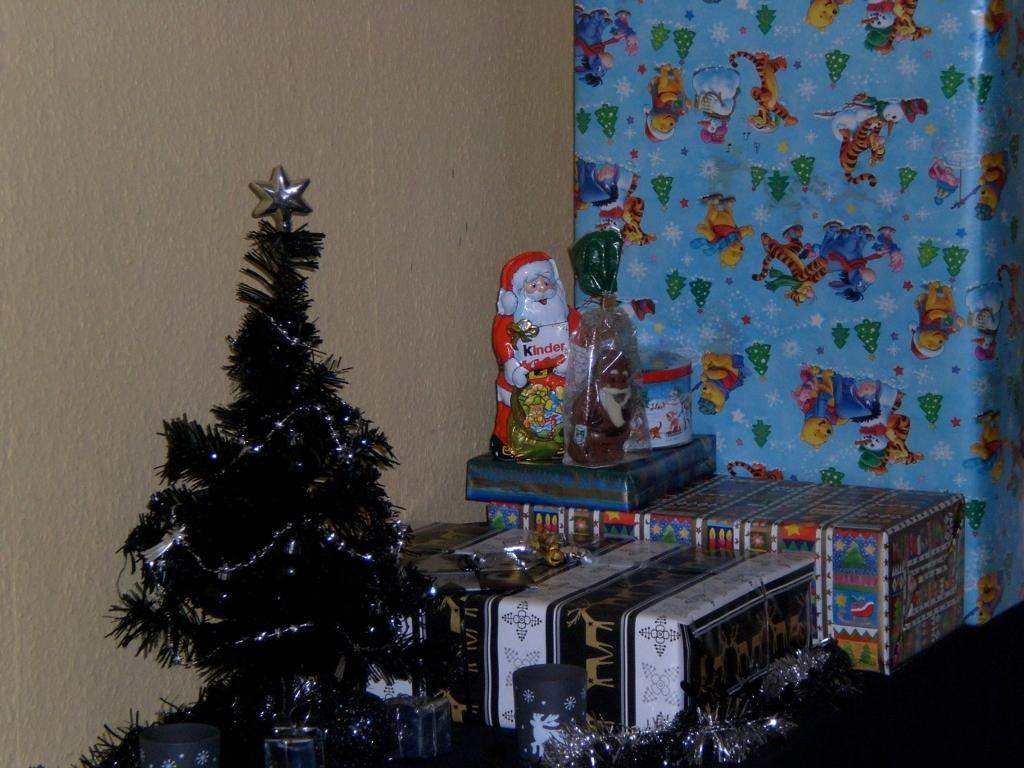What is the main structure in the image? There is a wall in the image. What is placed in front of the wall? There is a Christmas tree and a Santa Claus doll in front of the wall. What else can be seen in front of the wall? There are gift boxes in front of the wall. What type of tableware is visible in the image? Cups are visible in the image. What type of needle is used to sew the Santa Claus doll in the image? There is no needle visible in the image, and the Santa Claus doll is a doll, not a real person. What direction is the zephyr blowing in the image? There is no mention of a zephyr in the image, as it is a gentle wind that is not present in this context. 